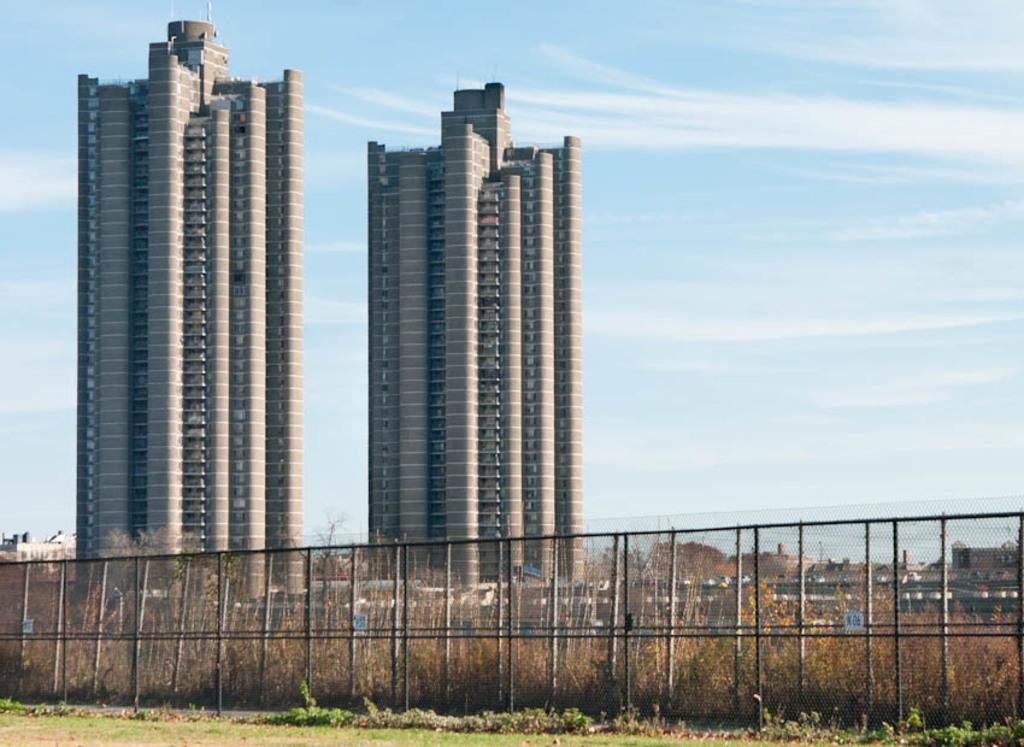What type of structures can be seen in the image? There are buildings in the image. What is the nature of the barrier in the image? There is fencing in the image. What type of vegetation is present in the image? Dry grass is visible in the image. What is the color of the sky in the image? The sky is blue and white in the image. How many bananas are hanging from the bridge in the image? There is no bridge or bananas present in the image. 